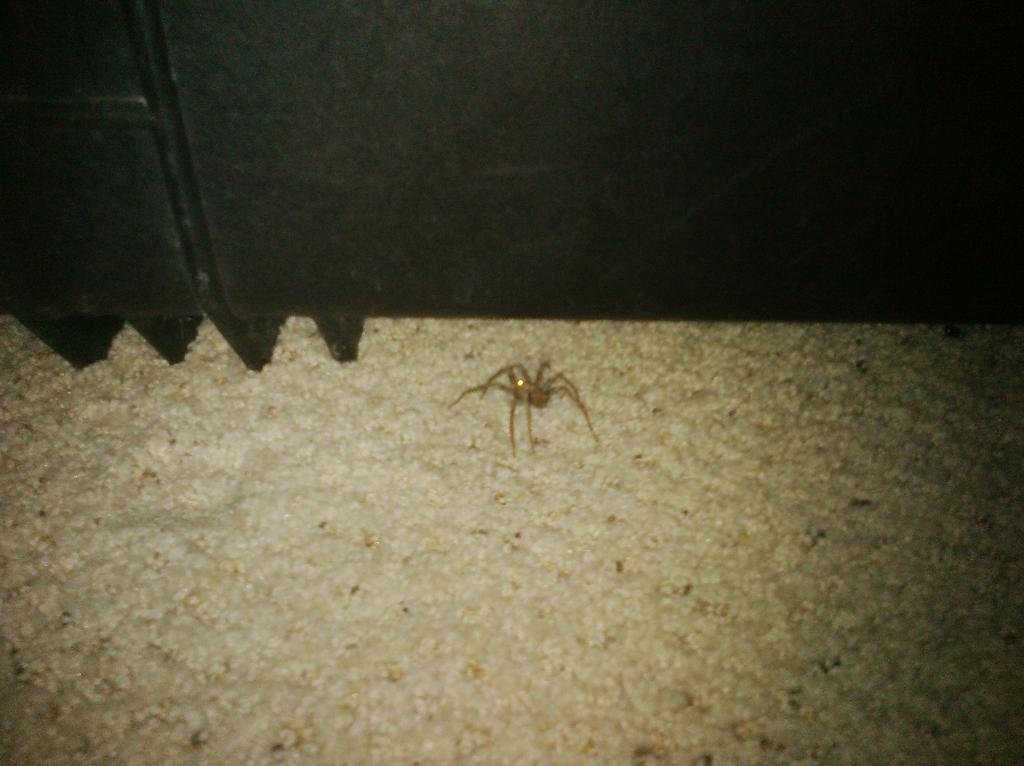Please provide a concise description of this image. In this image I can see a cream coloured spider. I can also see a black colour thing over here. 